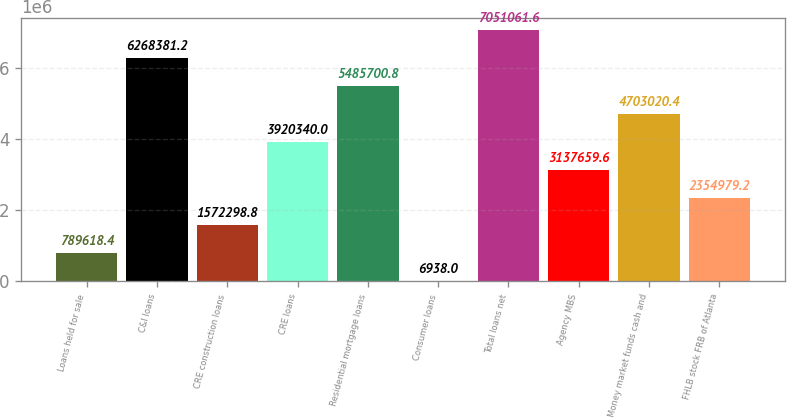<chart> <loc_0><loc_0><loc_500><loc_500><bar_chart><fcel>Loans held for sale<fcel>C&I loans<fcel>CRE construction loans<fcel>CRE loans<fcel>Residential mortgage loans<fcel>Consumer loans<fcel>Total loans net<fcel>Agency MBS<fcel>Money market funds cash and<fcel>FHLB stock FRB of Atlanta<nl><fcel>789618<fcel>6.26838e+06<fcel>1.5723e+06<fcel>3.92034e+06<fcel>5.4857e+06<fcel>6938<fcel>7.05106e+06<fcel>3.13766e+06<fcel>4.70302e+06<fcel>2.35498e+06<nl></chart> 